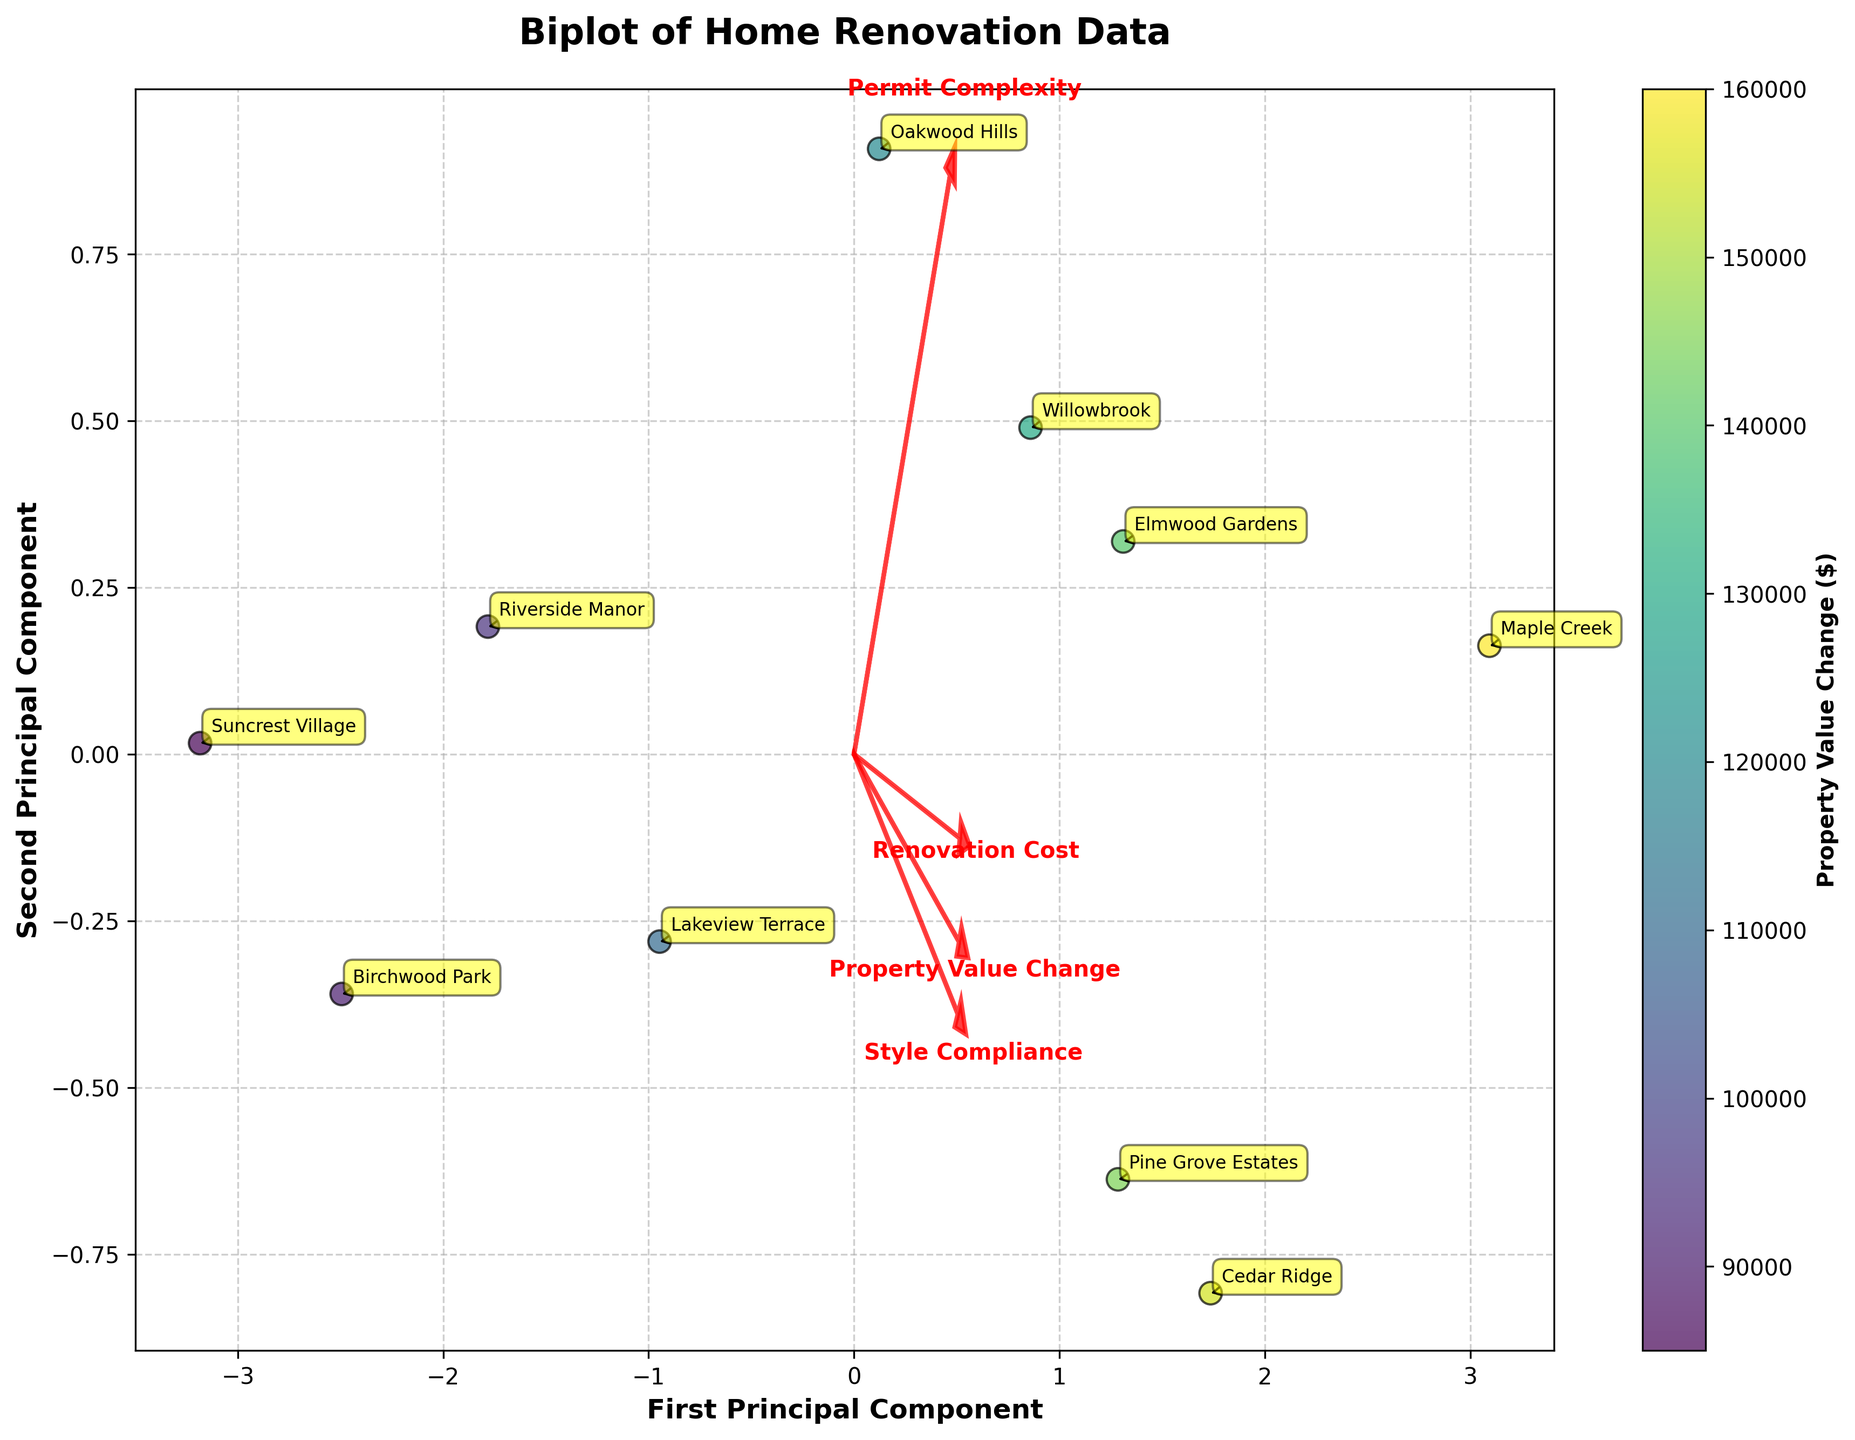What's the title of the plot? The title of the plot can be found at the top of the figure. This information is usually straightforward to identify as it is often in a larger and bolder font than other text elements.
Answer: Biplot of Home Renovation Data Which neighborhood had the lowest renovation cost? The neighborhood with the lowest renovation cost will typically be plotted closer to the origin of the biplot on the line representing renovation cost. Checking the color map may also help if renovation costs are color-coded.
Answer: Suncrest Village How many neighborhoods have a property value change above $100,000? To find this, we need to count the number of points that correspond to neighborhoods with a property value change above $100,000. Since the color map represents property value change, we look for points with a color representing values above $100,000.
Answer: 7 Which feature vector is the most extended in the biplot? The feature vectors are represented by arrows in the biplot. The one that extends the farthest from the origin indicates a feature with the highest variance in the data set. By looking at the plot, we can determine which arrow is the longest.
Answer: Style Compliance Between "Elmwood Gardens" and "Willowbrook," which neighborhood has a higher influence on the first principal component? To solve this, we compare the x-coordinates of "Elmwood Gardens" and "Willowbrook" on the biplot. The neighborhood with the higher x-coordinate influences the first principal component more.
Answer: Elmwood Gardens Which features have a positive correlation with each other? Features with positive correlations will have arrows pointing in similar directions on the biplot. By examining the directions of the arrows representing each feature, we can determine which features are positively correlated.
Answer: Style Compliance & Permit Complexity What is the relative position of "Maple Creek" compared to the origin in terms of the first and second principal components? To describe this, we look at how far "Maple Creek" is along the x-axis and y-axis compared to the origin. This will indicate its relative position in both principal components.
Answer: Positive in both components How does "Pine Grove Estates" compare to "Birchwood Park" in terms of property value change? To compare these neighborhoods, we look at the colors of the points representing them, as the color map indicates property value change values.
Answer: Higher Does "Cedar Ridge" have a higher or lower complexity of obtaining permits compared to "Riverside Manor"? To find this out, we need to compare the positions of "Cedar Ridge" and "Riverside Manor" along the arrow representing "Permit Complexity." The point farther along the arrow has higher permit complexity.
Answer: Higher 